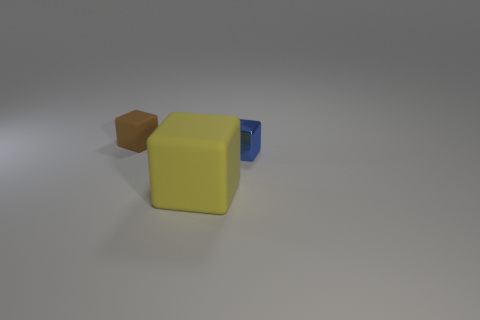Is there anything else that is the same size as the yellow matte cube?
Provide a short and direct response. No. There is a block that is to the left of the large object; are there any tiny rubber cubes behind it?
Your answer should be very brief. No. There is a big yellow object that is the same shape as the tiny metal thing; what is its material?
Your answer should be compact. Rubber. What number of tiny brown matte blocks are in front of the matte object in front of the small rubber block?
Make the answer very short. 0. Are there any other things that are the same color as the large cube?
Provide a succinct answer. No. How many objects are either tiny matte things or tiny things that are behind the small blue object?
Your answer should be very brief. 1. There is a small thing that is in front of the rubber cube that is behind the matte thing that is right of the brown object; what is it made of?
Give a very brief answer. Metal. There is a object that is the same material as the brown cube; what size is it?
Give a very brief answer. Large. The tiny block that is on the left side of the thing that is in front of the blue shiny cube is what color?
Make the answer very short. Brown. What number of other large things are made of the same material as the blue thing?
Offer a very short reply. 0. 